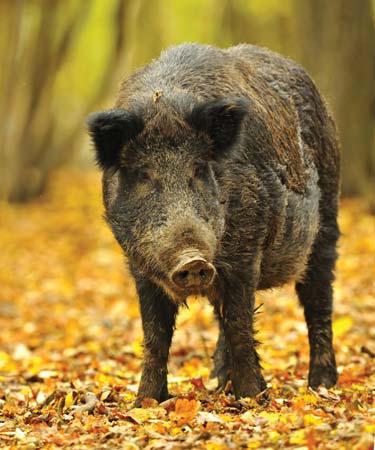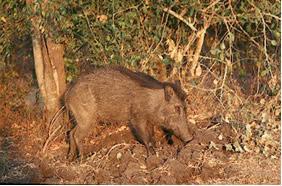The first image is the image on the left, the second image is the image on the right. For the images shown, is this caption "In one image, the animals are standing on grass that is green." true? Answer yes or no. No. The first image is the image on the left, the second image is the image on the right. Examine the images to the left and right. Is the description "The pigs are standing on yellow leaves in one image and not in the other." accurate? Answer yes or no. Yes. 